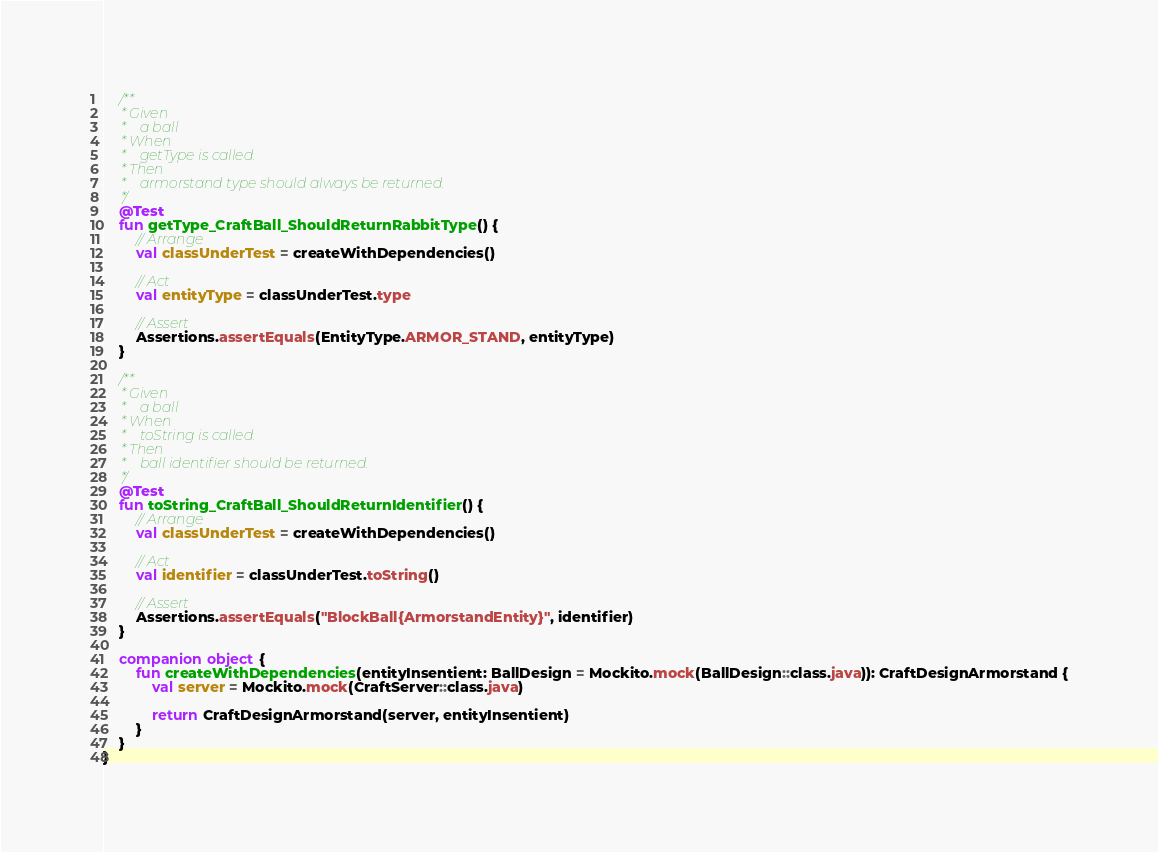<code> <loc_0><loc_0><loc_500><loc_500><_Kotlin_>
    /**
     * Given
     *    a ball
     * When
     *    getType is called.
     * Then
     *    armorstand type should always be returned.
     */
    @Test
    fun getType_CraftBall_ShouldReturnRabbitType() {
        // Arrange
        val classUnderTest = createWithDependencies()

        // Act
        val entityType = classUnderTest.type

        // Assert
        Assertions.assertEquals(EntityType.ARMOR_STAND, entityType)
    }

    /**
     * Given
     *    a ball
     * When
     *    toString is called.
     * Then
     *    ball identifier should be returned.
     */
    @Test
    fun toString_CraftBall_ShouldReturnIdentifier() {
        // Arrange
        val classUnderTest = createWithDependencies()

        // Act
        val identifier = classUnderTest.toString()

        // Assert
        Assertions.assertEquals("BlockBall{ArmorstandEntity}", identifier)
    }

    companion object {
        fun createWithDependencies(entityInsentient: BallDesign = Mockito.mock(BallDesign::class.java)): CraftDesignArmorstand {
            val server = Mockito.mock(CraftServer::class.java)

            return CraftDesignArmorstand(server, entityInsentient)
        }
    }
}</code> 